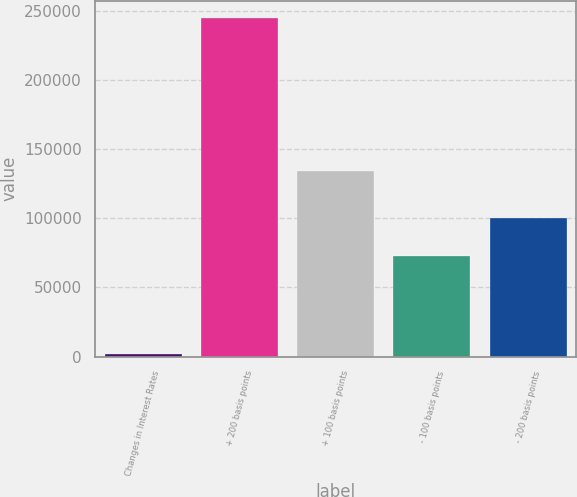Convert chart. <chart><loc_0><loc_0><loc_500><loc_500><bar_chart><fcel>Changes in Interest Rates<fcel>+ 200 basis points<fcel>+ 100 basis points<fcel>- 100 basis points<fcel>- 200 basis points<nl><fcel>2013<fcel>245089<fcel>134188<fcel>72755<fcel>100543<nl></chart> 